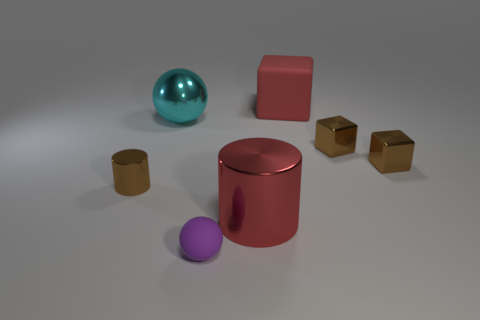There is a big metal thing that is the same color as the large rubber block; what shape is it?
Provide a succinct answer. Cylinder. What is the material of the thing that is the same color as the rubber cube?
Provide a short and direct response. Metal. There is a cube that is the same size as the cyan thing; what is it made of?
Provide a short and direct response. Rubber. Is the size of the metal object that is in front of the brown shiny cylinder the same as the tiny cylinder?
Keep it short and to the point. No. Is the shape of the red object that is on the right side of the red cylinder the same as  the cyan object?
Provide a succinct answer. No. What number of objects are either large gray rubber objects or big shiny objects that are on the left side of the purple matte sphere?
Your answer should be compact. 1. Is the number of brown cylinders less than the number of small yellow shiny things?
Your answer should be very brief. No. Is the number of small brown cubes greater than the number of cyan things?
Provide a short and direct response. Yes. What number of other objects are the same material as the tiny purple thing?
Give a very brief answer. 1. How many cyan balls are on the right side of the matte thing that is behind the large metallic object left of the rubber sphere?
Your answer should be very brief. 0. 